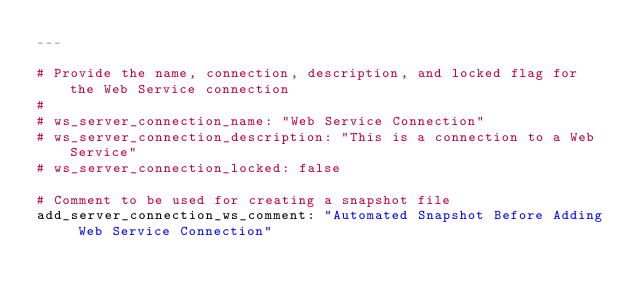<code> <loc_0><loc_0><loc_500><loc_500><_YAML_>---

# Provide the name, connection, description, and locked flag for the Web Service connection
#
# ws_server_connection_name: "Web Service Connection"
# ws_server_connection_description: "This is a connection to a Web Service"
# ws_server_connection_locked: false

# Comment to be used for creating a snapshot file
add_server_connection_ws_comment: "Automated Snapshot Before Adding Web Service Connection"
</code> 